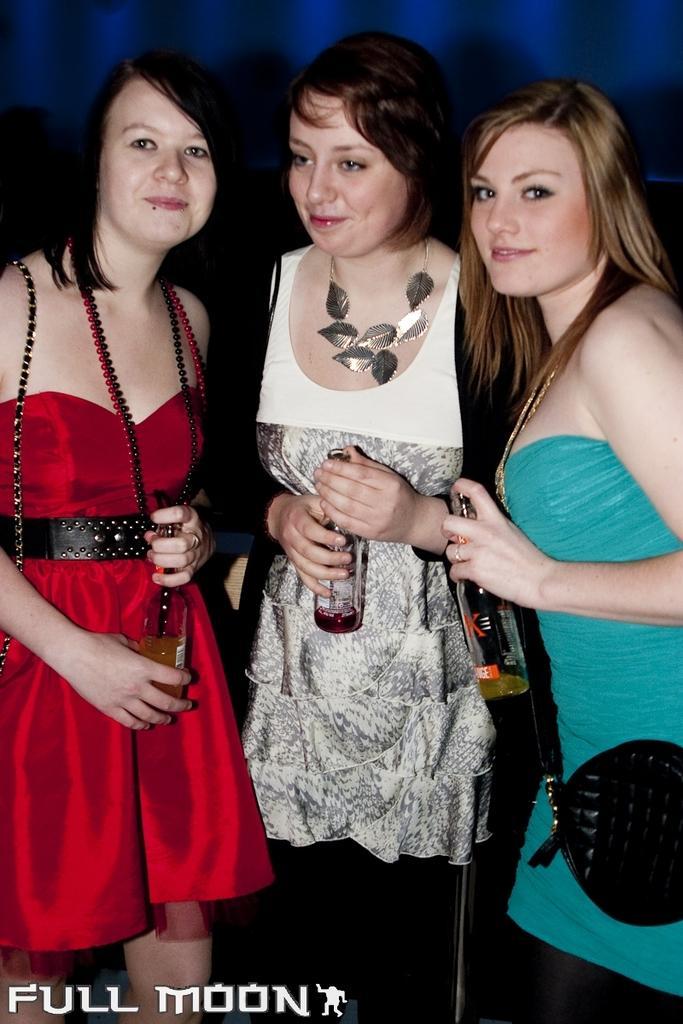Describe this image in one or two sentences. In this picture we can see three women standing and smiling and holding bottles with their hands. 